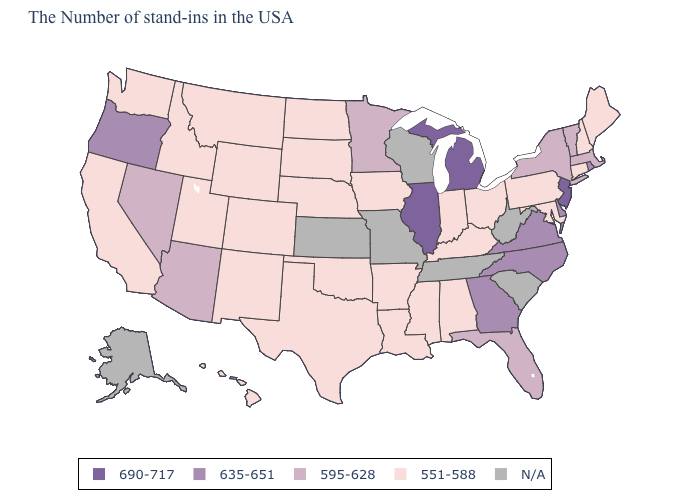Which states have the highest value in the USA?
Answer briefly. New Jersey, Michigan, Illinois. Which states have the highest value in the USA?
Write a very short answer. New Jersey, Michigan, Illinois. Which states have the lowest value in the West?
Short answer required. Wyoming, Colorado, New Mexico, Utah, Montana, Idaho, California, Washington, Hawaii. Which states have the lowest value in the USA?
Give a very brief answer. Maine, New Hampshire, Connecticut, Maryland, Pennsylvania, Ohio, Kentucky, Indiana, Alabama, Mississippi, Louisiana, Arkansas, Iowa, Nebraska, Oklahoma, Texas, South Dakota, North Dakota, Wyoming, Colorado, New Mexico, Utah, Montana, Idaho, California, Washington, Hawaii. Among the states that border Connecticut , does New York have the highest value?
Answer briefly. No. What is the value of California?
Concise answer only. 551-588. Among the states that border Pennsylvania , does New Jersey have the highest value?
Keep it brief. Yes. What is the highest value in the USA?
Short answer required. 690-717. Which states have the lowest value in the USA?
Answer briefly. Maine, New Hampshire, Connecticut, Maryland, Pennsylvania, Ohio, Kentucky, Indiana, Alabama, Mississippi, Louisiana, Arkansas, Iowa, Nebraska, Oklahoma, Texas, South Dakota, North Dakota, Wyoming, Colorado, New Mexico, Utah, Montana, Idaho, California, Washington, Hawaii. Name the states that have a value in the range 635-651?
Concise answer only. Rhode Island, Delaware, Virginia, North Carolina, Georgia, Oregon. Does New Jersey have the highest value in the USA?
Answer briefly. Yes. Is the legend a continuous bar?
Quick response, please. No. Which states have the lowest value in the West?
Quick response, please. Wyoming, Colorado, New Mexico, Utah, Montana, Idaho, California, Washington, Hawaii. 